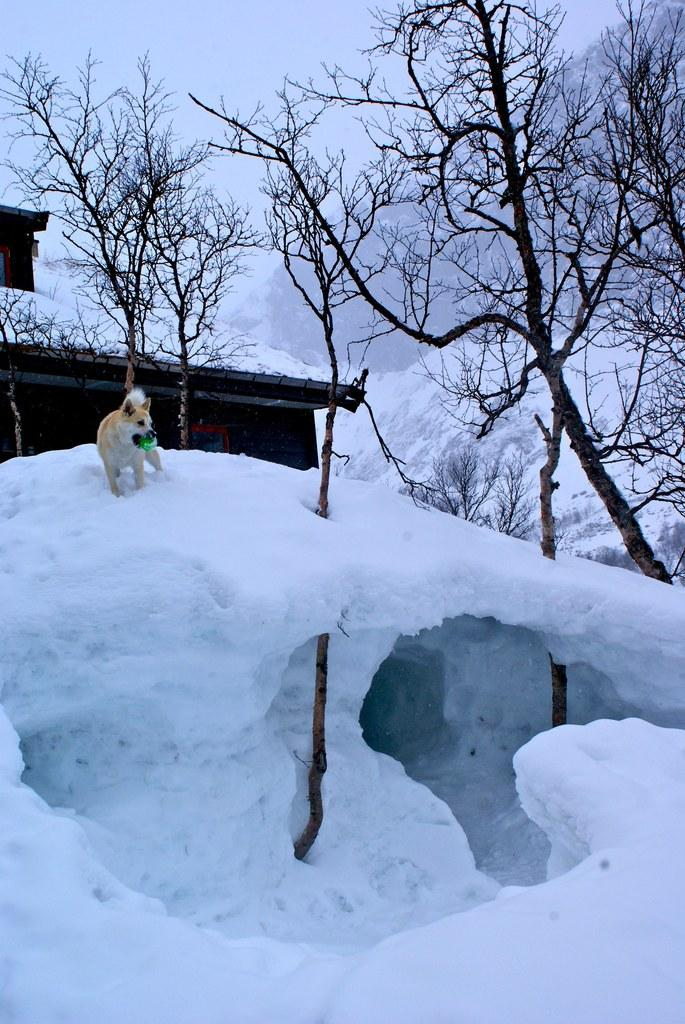What animal is present in the image? There is a dog in the image. What is the dog standing on? The dog is on the snow. Can you describe the dog's appearance? The dog has a white and brown color. What can be seen in the background of the image? There is a house, many trees, and the sky visible in the background of the image. What type of bomb is being diffused in the image? There is no bomb present in the image; it features a dog on the snow with a house, trees, and the sky in the background. 